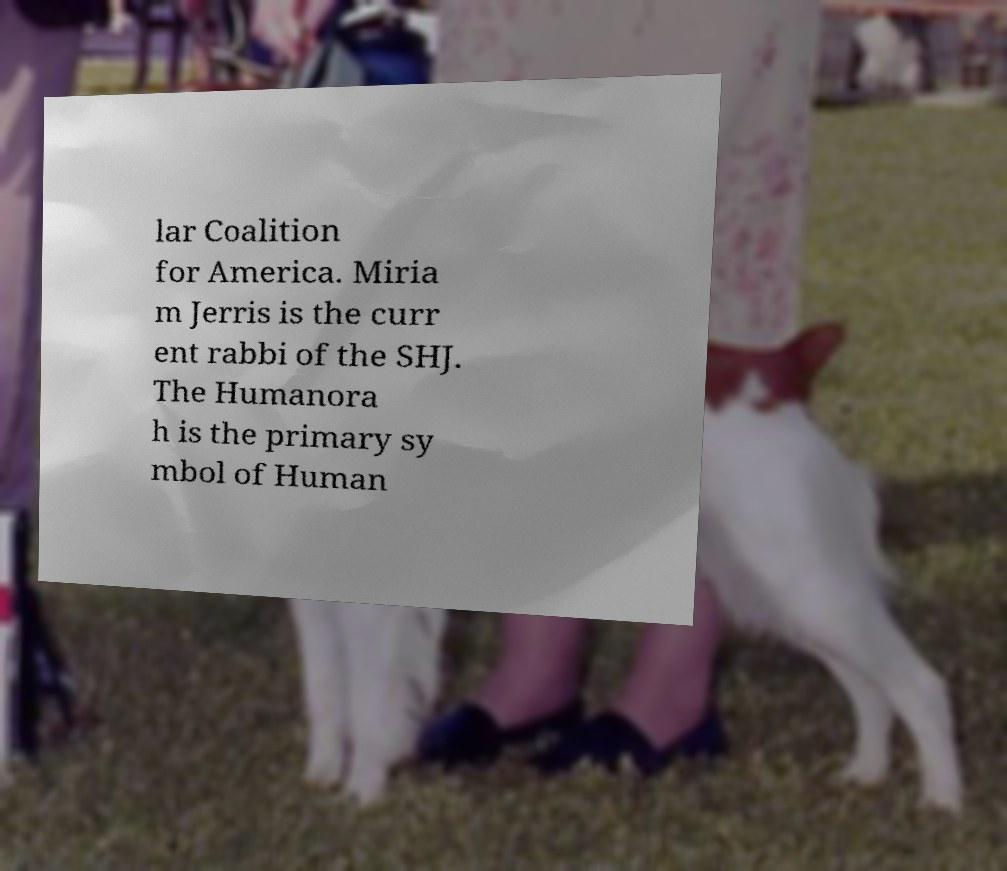Can you read and provide the text displayed in the image?This photo seems to have some interesting text. Can you extract and type it out for me? lar Coalition for America. Miria m Jerris is the curr ent rabbi of the SHJ. The Humanora h is the primary sy mbol of Human 